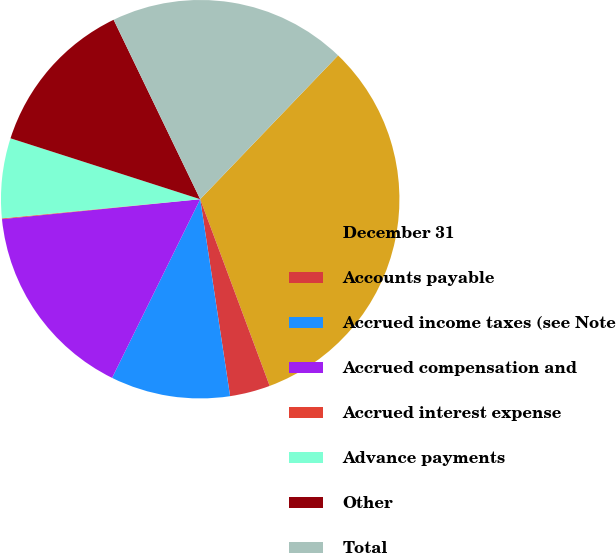<chart> <loc_0><loc_0><loc_500><loc_500><pie_chart><fcel>December 31<fcel>Accounts payable<fcel>Accrued income taxes (see Note<fcel>Accrued compensation and<fcel>Accrued interest expense<fcel>Advance payments<fcel>Other<fcel>Total<nl><fcel>32.16%<fcel>3.27%<fcel>9.69%<fcel>16.11%<fcel>0.06%<fcel>6.48%<fcel>12.9%<fcel>19.32%<nl></chart> 